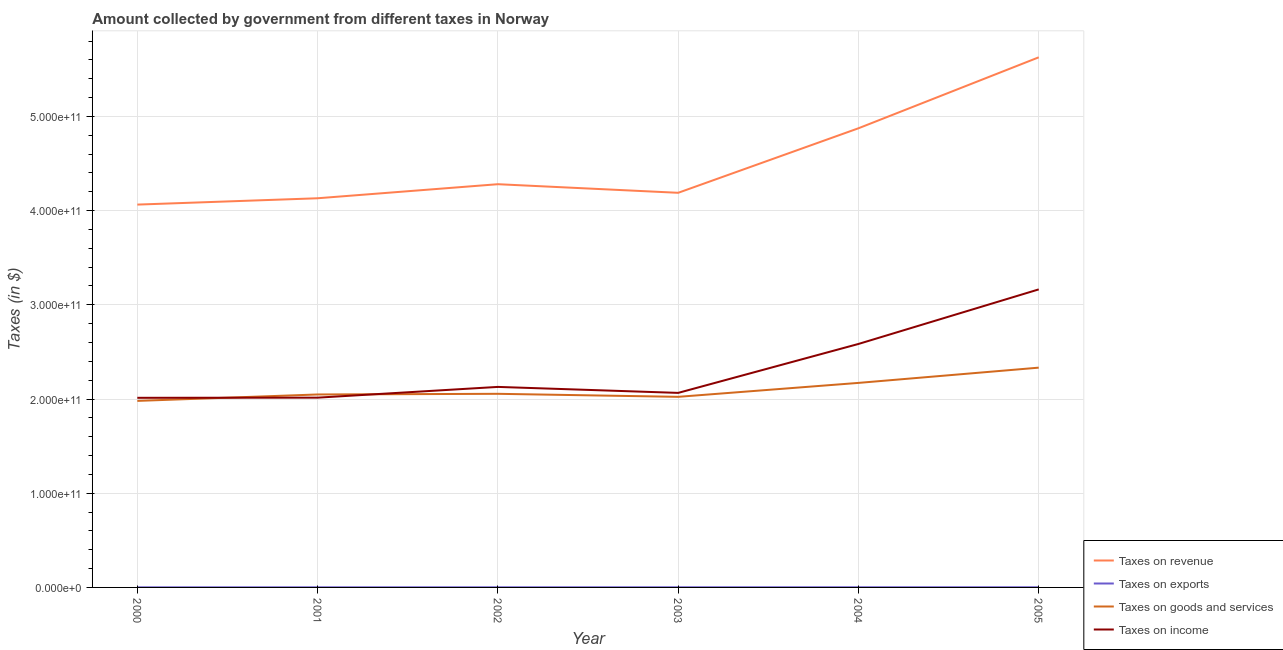Does the line corresponding to amount collected as tax on revenue intersect with the line corresponding to amount collected as tax on exports?
Your response must be concise. No. What is the amount collected as tax on goods in 2001?
Make the answer very short. 2.05e+11. Across all years, what is the maximum amount collected as tax on goods?
Give a very brief answer. 2.33e+11. Across all years, what is the minimum amount collected as tax on revenue?
Give a very brief answer. 4.06e+11. In which year was the amount collected as tax on exports minimum?
Your answer should be very brief. 2000. What is the total amount collected as tax on income in the graph?
Make the answer very short. 1.40e+12. What is the difference between the amount collected as tax on exports in 2003 and that in 2004?
Offer a very short reply. -2.00e+07. What is the difference between the amount collected as tax on income in 2002 and the amount collected as tax on revenue in 2001?
Your answer should be very brief. -2.00e+11. What is the average amount collected as tax on exports per year?
Ensure brevity in your answer.  1.42e+08. In the year 2000, what is the difference between the amount collected as tax on exports and amount collected as tax on revenue?
Keep it short and to the point. -4.06e+11. In how many years, is the amount collected as tax on exports greater than 160000000000 $?
Provide a succinct answer. 0. What is the ratio of the amount collected as tax on exports in 2002 to that in 2003?
Your response must be concise. 0.87. Is the amount collected as tax on goods in 2001 less than that in 2002?
Keep it short and to the point. Yes. What is the difference between the highest and the second highest amount collected as tax on exports?
Your answer should be very brief. 0. What is the difference between the highest and the lowest amount collected as tax on exports?
Give a very brief answer. 6.00e+07. Is it the case that in every year, the sum of the amount collected as tax on revenue and amount collected as tax on income is greater than the sum of amount collected as tax on goods and amount collected as tax on exports?
Offer a terse response. Yes. Is it the case that in every year, the sum of the amount collected as tax on revenue and amount collected as tax on exports is greater than the amount collected as tax on goods?
Your response must be concise. Yes. Does the amount collected as tax on exports monotonically increase over the years?
Your answer should be compact. No. Is the amount collected as tax on goods strictly greater than the amount collected as tax on income over the years?
Your answer should be very brief. No. Is the amount collected as tax on exports strictly less than the amount collected as tax on income over the years?
Your answer should be compact. Yes. How many lines are there?
Provide a short and direct response. 4. What is the difference between two consecutive major ticks on the Y-axis?
Provide a short and direct response. 1.00e+11. Does the graph contain any zero values?
Provide a short and direct response. No. Where does the legend appear in the graph?
Offer a very short reply. Bottom right. How are the legend labels stacked?
Provide a short and direct response. Vertical. What is the title of the graph?
Give a very brief answer. Amount collected by government from different taxes in Norway. What is the label or title of the X-axis?
Ensure brevity in your answer.  Year. What is the label or title of the Y-axis?
Offer a terse response. Taxes (in $). What is the Taxes (in $) in Taxes on revenue in 2000?
Give a very brief answer. 4.06e+11. What is the Taxes (in $) of Taxes on exports in 2000?
Your answer should be compact. 1.10e+08. What is the Taxes (in $) of Taxes on goods and services in 2000?
Ensure brevity in your answer.  1.98e+11. What is the Taxes (in $) in Taxes on income in 2000?
Provide a short and direct response. 2.01e+11. What is the Taxes (in $) of Taxes on revenue in 2001?
Keep it short and to the point. 4.13e+11. What is the Taxes (in $) in Taxes on exports in 2001?
Offer a very short reply. 1.20e+08. What is the Taxes (in $) of Taxes on goods and services in 2001?
Give a very brief answer. 2.05e+11. What is the Taxes (in $) of Taxes on income in 2001?
Provide a succinct answer. 2.01e+11. What is the Taxes (in $) of Taxes on revenue in 2002?
Give a very brief answer. 4.28e+11. What is the Taxes (in $) in Taxes on exports in 2002?
Your answer should be compact. 1.30e+08. What is the Taxes (in $) of Taxes on goods and services in 2002?
Provide a succinct answer. 2.06e+11. What is the Taxes (in $) in Taxes on income in 2002?
Make the answer very short. 2.13e+11. What is the Taxes (in $) in Taxes on revenue in 2003?
Your response must be concise. 4.19e+11. What is the Taxes (in $) of Taxes on exports in 2003?
Your answer should be very brief. 1.50e+08. What is the Taxes (in $) of Taxes on goods and services in 2003?
Your answer should be very brief. 2.02e+11. What is the Taxes (in $) in Taxes on income in 2003?
Make the answer very short. 2.06e+11. What is the Taxes (in $) in Taxes on revenue in 2004?
Your answer should be very brief. 4.87e+11. What is the Taxes (in $) of Taxes on exports in 2004?
Your response must be concise. 1.70e+08. What is the Taxes (in $) of Taxes on goods and services in 2004?
Make the answer very short. 2.17e+11. What is the Taxes (in $) of Taxes on income in 2004?
Offer a very short reply. 2.58e+11. What is the Taxes (in $) in Taxes on revenue in 2005?
Provide a succinct answer. 5.63e+11. What is the Taxes (in $) of Taxes on exports in 2005?
Your answer should be compact. 1.70e+08. What is the Taxes (in $) of Taxes on goods and services in 2005?
Offer a very short reply. 2.33e+11. What is the Taxes (in $) in Taxes on income in 2005?
Your answer should be compact. 3.16e+11. Across all years, what is the maximum Taxes (in $) of Taxes on revenue?
Provide a succinct answer. 5.63e+11. Across all years, what is the maximum Taxes (in $) of Taxes on exports?
Your response must be concise. 1.70e+08. Across all years, what is the maximum Taxes (in $) of Taxes on goods and services?
Provide a short and direct response. 2.33e+11. Across all years, what is the maximum Taxes (in $) of Taxes on income?
Your answer should be very brief. 3.16e+11. Across all years, what is the minimum Taxes (in $) of Taxes on revenue?
Offer a terse response. 4.06e+11. Across all years, what is the minimum Taxes (in $) of Taxes on exports?
Ensure brevity in your answer.  1.10e+08. Across all years, what is the minimum Taxes (in $) of Taxes on goods and services?
Your response must be concise. 1.98e+11. Across all years, what is the minimum Taxes (in $) in Taxes on income?
Provide a short and direct response. 2.01e+11. What is the total Taxes (in $) in Taxes on revenue in the graph?
Your response must be concise. 2.72e+12. What is the total Taxes (in $) in Taxes on exports in the graph?
Your response must be concise. 8.50e+08. What is the total Taxes (in $) of Taxes on goods and services in the graph?
Your answer should be compact. 1.26e+12. What is the total Taxes (in $) in Taxes on income in the graph?
Provide a succinct answer. 1.40e+12. What is the difference between the Taxes (in $) of Taxes on revenue in 2000 and that in 2001?
Offer a terse response. -6.72e+09. What is the difference between the Taxes (in $) of Taxes on exports in 2000 and that in 2001?
Provide a short and direct response. -1.00e+07. What is the difference between the Taxes (in $) in Taxes on goods and services in 2000 and that in 2001?
Make the answer very short. -6.82e+09. What is the difference between the Taxes (in $) of Taxes on income in 2000 and that in 2001?
Provide a short and direct response. -1.79e+08. What is the difference between the Taxes (in $) in Taxes on revenue in 2000 and that in 2002?
Ensure brevity in your answer.  -2.16e+1. What is the difference between the Taxes (in $) of Taxes on exports in 2000 and that in 2002?
Your response must be concise. -2.00e+07. What is the difference between the Taxes (in $) in Taxes on goods and services in 2000 and that in 2002?
Offer a very short reply. -7.52e+09. What is the difference between the Taxes (in $) in Taxes on income in 2000 and that in 2002?
Provide a short and direct response. -1.16e+1. What is the difference between the Taxes (in $) of Taxes on revenue in 2000 and that in 2003?
Your answer should be compact. -1.25e+1. What is the difference between the Taxes (in $) of Taxes on exports in 2000 and that in 2003?
Give a very brief answer. -4.00e+07. What is the difference between the Taxes (in $) of Taxes on goods and services in 2000 and that in 2003?
Ensure brevity in your answer.  -4.31e+09. What is the difference between the Taxes (in $) in Taxes on income in 2000 and that in 2003?
Your response must be concise. -5.23e+09. What is the difference between the Taxes (in $) in Taxes on revenue in 2000 and that in 2004?
Provide a short and direct response. -8.10e+1. What is the difference between the Taxes (in $) of Taxes on exports in 2000 and that in 2004?
Provide a short and direct response. -6.00e+07. What is the difference between the Taxes (in $) of Taxes on goods and services in 2000 and that in 2004?
Offer a very short reply. -1.91e+1. What is the difference between the Taxes (in $) in Taxes on income in 2000 and that in 2004?
Keep it short and to the point. -5.72e+1. What is the difference between the Taxes (in $) of Taxes on revenue in 2000 and that in 2005?
Give a very brief answer. -1.56e+11. What is the difference between the Taxes (in $) of Taxes on exports in 2000 and that in 2005?
Your answer should be compact. -6.00e+07. What is the difference between the Taxes (in $) of Taxes on goods and services in 2000 and that in 2005?
Make the answer very short. -3.53e+1. What is the difference between the Taxes (in $) of Taxes on income in 2000 and that in 2005?
Ensure brevity in your answer.  -1.15e+11. What is the difference between the Taxes (in $) in Taxes on revenue in 2001 and that in 2002?
Offer a terse response. -1.49e+1. What is the difference between the Taxes (in $) of Taxes on exports in 2001 and that in 2002?
Provide a succinct answer. -1.00e+07. What is the difference between the Taxes (in $) of Taxes on goods and services in 2001 and that in 2002?
Make the answer very short. -6.98e+08. What is the difference between the Taxes (in $) of Taxes on income in 2001 and that in 2002?
Give a very brief answer. -1.14e+1. What is the difference between the Taxes (in $) of Taxes on revenue in 2001 and that in 2003?
Provide a short and direct response. -5.80e+09. What is the difference between the Taxes (in $) of Taxes on exports in 2001 and that in 2003?
Offer a terse response. -3.00e+07. What is the difference between the Taxes (in $) of Taxes on goods and services in 2001 and that in 2003?
Provide a succinct answer. 2.51e+09. What is the difference between the Taxes (in $) in Taxes on income in 2001 and that in 2003?
Give a very brief answer. -5.05e+09. What is the difference between the Taxes (in $) in Taxes on revenue in 2001 and that in 2004?
Your response must be concise. -7.43e+1. What is the difference between the Taxes (in $) of Taxes on exports in 2001 and that in 2004?
Keep it short and to the point. -5.00e+07. What is the difference between the Taxes (in $) in Taxes on goods and services in 2001 and that in 2004?
Your answer should be very brief. -1.23e+1. What is the difference between the Taxes (in $) in Taxes on income in 2001 and that in 2004?
Give a very brief answer. -5.70e+1. What is the difference between the Taxes (in $) in Taxes on revenue in 2001 and that in 2005?
Offer a very short reply. -1.50e+11. What is the difference between the Taxes (in $) of Taxes on exports in 2001 and that in 2005?
Offer a terse response. -5.00e+07. What is the difference between the Taxes (in $) in Taxes on goods and services in 2001 and that in 2005?
Make the answer very short. -2.85e+1. What is the difference between the Taxes (in $) in Taxes on income in 2001 and that in 2005?
Offer a very short reply. -1.15e+11. What is the difference between the Taxes (in $) in Taxes on revenue in 2002 and that in 2003?
Your answer should be compact. 9.12e+09. What is the difference between the Taxes (in $) in Taxes on exports in 2002 and that in 2003?
Your answer should be compact. -2.00e+07. What is the difference between the Taxes (in $) in Taxes on goods and services in 2002 and that in 2003?
Give a very brief answer. 3.21e+09. What is the difference between the Taxes (in $) in Taxes on income in 2002 and that in 2003?
Give a very brief answer. 6.36e+09. What is the difference between the Taxes (in $) of Taxes on revenue in 2002 and that in 2004?
Provide a succinct answer. -5.94e+1. What is the difference between the Taxes (in $) of Taxes on exports in 2002 and that in 2004?
Your response must be concise. -4.00e+07. What is the difference between the Taxes (in $) in Taxes on goods and services in 2002 and that in 2004?
Make the answer very short. -1.16e+1. What is the difference between the Taxes (in $) of Taxes on income in 2002 and that in 2004?
Ensure brevity in your answer.  -4.56e+1. What is the difference between the Taxes (in $) in Taxes on revenue in 2002 and that in 2005?
Your response must be concise. -1.35e+11. What is the difference between the Taxes (in $) in Taxes on exports in 2002 and that in 2005?
Provide a succinct answer. -4.00e+07. What is the difference between the Taxes (in $) of Taxes on goods and services in 2002 and that in 2005?
Offer a terse response. -2.78e+1. What is the difference between the Taxes (in $) of Taxes on income in 2002 and that in 2005?
Provide a succinct answer. -1.04e+11. What is the difference between the Taxes (in $) of Taxes on revenue in 2003 and that in 2004?
Provide a succinct answer. -6.85e+1. What is the difference between the Taxes (in $) of Taxes on exports in 2003 and that in 2004?
Give a very brief answer. -2.00e+07. What is the difference between the Taxes (in $) of Taxes on goods and services in 2003 and that in 2004?
Your response must be concise. -1.48e+1. What is the difference between the Taxes (in $) of Taxes on income in 2003 and that in 2004?
Provide a succinct answer. -5.19e+1. What is the difference between the Taxes (in $) of Taxes on revenue in 2003 and that in 2005?
Offer a terse response. -1.44e+11. What is the difference between the Taxes (in $) in Taxes on exports in 2003 and that in 2005?
Make the answer very short. -2.00e+07. What is the difference between the Taxes (in $) of Taxes on goods and services in 2003 and that in 2005?
Offer a terse response. -3.10e+1. What is the difference between the Taxes (in $) of Taxes on income in 2003 and that in 2005?
Your answer should be compact. -1.10e+11. What is the difference between the Taxes (in $) of Taxes on revenue in 2004 and that in 2005?
Your answer should be compact. -7.53e+1. What is the difference between the Taxes (in $) of Taxes on exports in 2004 and that in 2005?
Provide a short and direct response. 0. What is the difference between the Taxes (in $) in Taxes on goods and services in 2004 and that in 2005?
Offer a terse response. -1.62e+1. What is the difference between the Taxes (in $) in Taxes on income in 2004 and that in 2005?
Make the answer very short. -5.79e+1. What is the difference between the Taxes (in $) of Taxes on revenue in 2000 and the Taxes (in $) of Taxes on exports in 2001?
Your answer should be very brief. 4.06e+11. What is the difference between the Taxes (in $) of Taxes on revenue in 2000 and the Taxes (in $) of Taxes on goods and services in 2001?
Your answer should be compact. 2.02e+11. What is the difference between the Taxes (in $) of Taxes on revenue in 2000 and the Taxes (in $) of Taxes on income in 2001?
Offer a terse response. 2.05e+11. What is the difference between the Taxes (in $) of Taxes on exports in 2000 and the Taxes (in $) of Taxes on goods and services in 2001?
Offer a very short reply. -2.05e+11. What is the difference between the Taxes (in $) in Taxes on exports in 2000 and the Taxes (in $) in Taxes on income in 2001?
Ensure brevity in your answer.  -2.01e+11. What is the difference between the Taxes (in $) in Taxes on goods and services in 2000 and the Taxes (in $) in Taxes on income in 2001?
Offer a terse response. -3.44e+09. What is the difference between the Taxes (in $) in Taxes on revenue in 2000 and the Taxes (in $) in Taxes on exports in 2002?
Give a very brief answer. 4.06e+11. What is the difference between the Taxes (in $) of Taxes on revenue in 2000 and the Taxes (in $) of Taxes on goods and services in 2002?
Offer a very short reply. 2.01e+11. What is the difference between the Taxes (in $) in Taxes on revenue in 2000 and the Taxes (in $) in Taxes on income in 2002?
Give a very brief answer. 1.94e+11. What is the difference between the Taxes (in $) of Taxes on exports in 2000 and the Taxes (in $) of Taxes on goods and services in 2002?
Offer a very short reply. -2.05e+11. What is the difference between the Taxes (in $) in Taxes on exports in 2000 and the Taxes (in $) in Taxes on income in 2002?
Your answer should be very brief. -2.13e+11. What is the difference between the Taxes (in $) of Taxes on goods and services in 2000 and the Taxes (in $) of Taxes on income in 2002?
Offer a very short reply. -1.49e+1. What is the difference between the Taxes (in $) in Taxes on revenue in 2000 and the Taxes (in $) in Taxes on exports in 2003?
Provide a succinct answer. 4.06e+11. What is the difference between the Taxes (in $) in Taxes on revenue in 2000 and the Taxes (in $) in Taxes on goods and services in 2003?
Your response must be concise. 2.04e+11. What is the difference between the Taxes (in $) in Taxes on revenue in 2000 and the Taxes (in $) in Taxes on income in 2003?
Give a very brief answer. 2.00e+11. What is the difference between the Taxes (in $) of Taxes on exports in 2000 and the Taxes (in $) of Taxes on goods and services in 2003?
Give a very brief answer. -2.02e+11. What is the difference between the Taxes (in $) in Taxes on exports in 2000 and the Taxes (in $) in Taxes on income in 2003?
Make the answer very short. -2.06e+11. What is the difference between the Taxes (in $) of Taxes on goods and services in 2000 and the Taxes (in $) of Taxes on income in 2003?
Provide a short and direct response. -8.50e+09. What is the difference between the Taxes (in $) in Taxes on revenue in 2000 and the Taxes (in $) in Taxes on exports in 2004?
Your answer should be compact. 4.06e+11. What is the difference between the Taxes (in $) in Taxes on revenue in 2000 and the Taxes (in $) in Taxes on goods and services in 2004?
Your answer should be compact. 1.89e+11. What is the difference between the Taxes (in $) in Taxes on revenue in 2000 and the Taxes (in $) in Taxes on income in 2004?
Make the answer very short. 1.48e+11. What is the difference between the Taxes (in $) in Taxes on exports in 2000 and the Taxes (in $) in Taxes on goods and services in 2004?
Provide a succinct answer. -2.17e+11. What is the difference between the Taxes (in $) of Taxes on exports in 2000 and the Taxes (in $) of Taxes on income in 2004?
Make the answer very short. -2.58e+11. What is the difference between the Taxes (in $) in Taxes on goods and services in 2000 and the Taxes (in $) in Taxes on income in 2004?
Your answer should be compact. -6.04e+1. What is the difference between the Taxes (in $) of Taxes on revenue in 2000 and the Taxes (in $) of Taxes on exports in 2005?
Offer a very short reply. 4.06e+11. What is the difference between the Taxes (in $) in Taxes on revenue in 2000 and the Taxes (in $) in Taxes on goods and services in 2005?
Provide a succinct answer. 1.73e+11. What is the difference between the Taxes (in $) of Taxes on revenue in 2000 and the Taxes (in $) of Taxes on income in 2005?
Ensure brevity in your answer.  9.00e+1. What is the difference between the Taxes (in $) of Taxes on exports in 2000 and the Taxes (in $) of Taxes on goods and services in 2005?
Offer a very short reply. -2.33e+11. What is the difference between the Taxes (in $) in Taxes on exports in 2000 and the Taxes (in $) in Taxes on income in 2005?
Keep it short and to the point. -3.16e+11. What is the difference between the Taxes (in $) of Taxes on goods and services in 2000 and the Taxes (in $) of Taxes on income in 2005?
Give a very brief answer. -1.18e+11. What is the difference between the Taxes (in $) of Taxes on revenue in 2001 and the Taxes (in $) of Taxes on exports in 2002?
Provide a succinct answer. 4.13e+11. What is the difference between the Taxes (in $) of Taxes on revenue in 2001 and the Taxes (in $) of Taxes on goods and services in 2002?
Make the answer very short. 2.08e+11. What is the difference between the Taxes (in $) of Taxes on revenue in 2001 and the Taxes (in $) of Taxes on income in 2002?
Offer a terse response. 2.00e+11. What is the difference between the Taxes (in $) of Taxes on exports in 2001 and the Taxes (in $) of Taxes on goods and services in 2002?
Your answer should be compact. -2.05e+11. What is the difference between the Taxes (in $) in Taxes on exports in 2001 and the Taxes (in $) in Taxes on income in 2002?
Your response must be concise. -2.13e+11. What is the difference between the Taxes (in $) of Taxes on goods and services in 2001 and the Taxes (in $) of Taxes on income in 2002?
Provide a succinct answer. -8.03e+09. What is the difference between the Taxes (in $) of Taxes on revenue in 2001 and the Taxes (in $) of Taxes on exports in 2003?
Your response must be concise. 4.13e+11. What is the difference between the Taxes (in $) in Taxes on revenue in 2001 and the Taxes (in $) in Taxes on goods and services in 2003?
Keep it short and to the point. 2.11e+11. What is the difference between the Taxes (in $) of Taxes on revenue in 2001 and the Taxes (in $) of Taxes on income in 2003?
Keep it short and to the point. 2.07e+11. What is the difference between the Taxes (in $) in Taxes on exports in 2001 and the Taxes (in $) in Taxes on goods and services in 2003?
Keep it short and to the point. -2.02e+11. What is the difference between the Taxes (in $) of Taxes on exports in 2001 and the Taxes (in $) of Taxes on income in 2003?
Provide a short and direct response. -2.06e+11. What is the difference between the Taxes (in $) in Taxes on goods and services in 2001 and the Taxes (in $) in Taxes on income in 2003?
Give a very brief answer. -1.67e+09. What is the difference between the Taxes (in $) of Taxes on revenue in 2001 and the Taxes (in $) of Taxes on exports in 2004?
Ensure brevity in your answer.  4.13e+11. What is the difference between the Taxes (in $) in Taxes on revenue in 2001 and the Taxes (in $) in Taxes on goods and services in 2004?
Offer a terse response. 1.96e+11. What is the difference between the Taxes (in $) of Taxes on revenue in 2001 and the Taxes (in $) of Taxes on income in 2004?
Your response must be concise. 1.55e+11. What is the difference between the Taxes (in $) of Taxes on exports in 2001 and the Taxes (in $) of Taxes on goods and services in 2004?
Offer a terse response. -2.17e+11. What is the difference between the Taxes (in $) of Taxes on exports in 2001 and the Taxes (in $) of Taxes on income in 2004?
Your answer should be compact. -2.58e+11. What is the difference between the Taxes (in $) in Taxes on goods and services in 2001 and the Taxes (in $) in Taxes on income in 2004?
Ensure brevity in your answer.  -5.36e+1. What is the difference between the Taxes (in $) of Taxes on revenue in 2001 and the Taxes (in $) of Taxes on exports in 2005?
Keep it short and to the point. 4.13e+11. What is the difference between the Taxes (in $) in Taxes on revenue in 2001 and the Taxes (in $) in Taxes on goods and services in 2005?
Your response must be concise. 1.80e+11. What is the difference between the Taxes (in $) of Taxes on revenue in 2001 and the Taxes (in $) of Taxes on income in 2005?
Make the answer very short. 9.67e+1. What is the difference between the Taxes (in $) in Taxes on exports in 2001 and the Taxes (in $) in Taxes on goods and services in 2005?
Offer a terse response. -2.33e+11. What is the difference between the Taxes (in $) of Taxes on exports in 2001 and the Taxes (in $) of Taxes on income in 2005?
Offer a terse response. -3.16e+11. What is the difference between the Taxes (in $) of Taxes on goods and services in 2001 and the Taxes (in $) of Taxes on income in 2005?
Offer a very short reply. -1.12e+11. What is the difference between the Taxes (in $) of Taxes on revenue in 2002 and the Taxes (in $) of Taxes on exports in 2003?
Keep it short and to the point. 4.28e+11. What is the difference between the Taxes (in $) of Taxes on revenue in 2002 and the Taxes (in $) of Taxes on goods and services in 2003?
Offer a terse response. 2.26e+11. What is the difference between the Taxes (in $) in Taxes on revenue in 2002 and the Taxes (in $) in Taxes on income in 2003?
Your answer should be compact. 2.22e+11. What is the difference between the Taxes (in $) in Taxes on exports in 2002 and the Taxes (in $) in Taxes on goods and services in 2003?
Provide a succinct answer. -2.02e+11. What is the difference between the Taxes (in $) in Taxes on exports in 2002 and the Taxes (in $) in Taxes on income in 2003?
Your answer should be compact. -2.06e+11. What is the difference between the Taxes (in $) of Taxes on goods and services in 2002 and the Taxes (in $) of Taxes on income in 2003?
Make the answer very short. -9.76e+08. What is the difference between the Taxes (in $) of Taxes on revenue in 2002 and the Taxes (in $) of Taxes on exports in 2004?
Make the answer very short. 4.28e+11. What is the difference between the Taxes (in $) of Taxes on revenue in 2002 and the Taxes (in $) of Taxes on goods and services in 2004?
Offer a very short reply. 2.11e+11. What is the difference between the Taxes (in $) in Taxes on revenue in 2002 and the Taxes (in $) in Taxes on income in 2004?
Keep it short and to the point. 1.70e+11. What is the difference between the Taxes (in $) in Taxes on exports in 2002 and the Taxes (in $) in Taxes on goods and services in 2004?
Provide a short and direct response. -2.17e+11. What is the difference between the Taxes (in $) of Taxes on exports in 2002 and the Taxes (in $) of Taxes on income in 2004?
Make the answer very short. -2.58e+11. What is the difference between the Taxes (in $) of Taxes on goods and services in 2002 and the Taxes (in $) of Taxes on income in 2004?
Offer a terse response. -5.29e+1. What is the difference between the Taxes (in $) in Taxes on revenue in 2002 and the Taxes (in $) in Taxes on exports in 2005?
Offer a terse response. 4.28e+11. What is the difference between the Taxes (in $) in Taxes on revenue in 2002 and the Taxes (in $) in Taxes on goods and services in 2005?
Offer a very short reply. 1.95e+11. What is the difference between the Taxes (in $) in Taxes on revenue in 2002 and the Taxes (in $) in Taxes on income in 2005?
Your answer should be compact. 1.12e+11. What is the difference between the Taxes (in $) of Taxes on exports in 2002 and the Taxes (in $) of Taxes on goods and services in 2005?
Provide a succinct answer. -2.33e+11. What is the difference between the Taxes (in $) of Taxes on exports in 2002 and the Taxes (in $) of Taxes on income in 2005?
Ensure brevity in your answer.  -3.16e+11. What is the difference between the Taxes (in $) of Taxes on goods and services in 2002 and the Taxes (in $) of Taxes on income in 2005?
Your answer should be very brief. -1.11e+11. What is the difference between the Taxes (in $) of Taxes on revenue in 2003 and the Taxes (in $) of Taxes on exports in 2004?
Provide a succinct answer. 4.19e+11. What is the difference between the Taxes (in $) in Taxes on revenue in 2003 and the Taxes (in $) in Taxes on goods and services in 2004?
Give a very brief answer. 2.02e+11. What is the difference between the Taxes (in $) in Taxes on revenue in 2003 and the Taxes (in $) in Taxes on income in 2004?
Give a very brief answer. 1.60e+11. What is the difference between the Taxes (in $) in Taxes on exports in 2003 and the Taxes (in $) in Taxes on goods and services in 2004?
Provide a succinct answer. -2.17e+11. What is the difference between the Taxes (in $) of Taxes on exports in 2003 and the Taxes (in $) of Taxes on income in 2004?
Your answer should be very brief. -2.58e+11. What is the difference between the Taxes (in $) of Taxes on goods and services in 2003 and the Taxes (in $) of Taxes on income in 2004?
Ensure brevity in your answer.  -5.61e+1. What is the difference between the Taxes (in $) of Taxes on revenue in 2003 and the Taxes (in $) of Taxes on exports in 2005?
Provide a short and direct response. 4.19e+11. What is the difference between the Taxes (in $) in Taxes on revenue in 2003 and the Taxes (in $) in Taxes on goods and services in 2005?
Offer a very short reply. 1.86e+11. What is the difference between the Taxes (in $) in Taxes on revenue in 2003 and the Taxes (in $) in Taxes on income in 2005?
Offer a terse response. 1.03e+11. What is the difference between the Taxes (in $) of Taxes on exports in 2003 and the Taxes (in $) of Taxes on goods and services in 2005?
Your answer should be compact. -2.33e+11. What is the difference between the Taxes (in $) of Taxes on exports in 2003 and the Taxes (in $) of Taxes on income in 2005?
Give a very brief answer. -3.16e+11. What is the difference between the Taxes (in $) in Taxes on goods and services in 2003 and the Taxes (in $) in Taxes on income in 2005?
Provide a succinct answer. -1.14e+11. What is the difference between the Taxes (in $) in Taxes on revenue in 2004 and the Taxes (in $) in Taxes on exports in 2005?
Ensure brevity in your answer.  4.87e+11. What is the difference between the Taxes (in $) of Taxes on revenue in 2004 and the Taxes (in $) of Taxes on goods and services in 2005?
Keep it short and to the point. 2.54e+11. What is the difference between the Taxes (in $) in Taxes on revenue in 2004 and the Taxes (in $) in Taxes on income in 2005?
Provide a succinct answer. 1.71e+11. What is the difference between the Taxes (in $) in Taxes on exports in 2004 and the Taxes (in $) in Taxes on goods and services in 2005?
Keep it short and to the point. -2.33e+11. What is the difference between the Taxes (in $) of Taxes on exports in 2004 and the Taxes (in $) of Taxes on income in 2005?
Give a very brief answer. -3.16e+11. What is the difference between the Taxes (in $) in Taxes on goods and services in 2004 and the Taxes (in $) in Taxes on income in 2005?
Offer a very short reply. -9.93e+1. What is the average Taxes (in $) of Taxes on revenue per year?
Offer a terse response. 4.53e+11. What is the average Taxes (in $) in Taxes on exports per year?
Offer a terse response. 1.42e+08. What is the average Taxes (in $) in Taxes on goods and services per year?
Provide a succinct answer. 2.10e+11. What is the average Taxes (in $) in Taxes on income per year?
Keep it short and to the point. 2.33e+11. In the year 2000, what is the difference between the Taxes (in $) in Taxes on revenue and Taxes (in $) in Taxes on exports?
Keep it short and to the point. 4.06e+11. In the year 2000, what is the difference between the Taxes (in $) of Taxes on revenue and Taxes (in $) of Taxes on goods and services?
Offer a terse response. 2.08e+11. In the year 2000, what is the difference between the Taxes (in $) in Taxes on revenue and Taxes (in $) in Taxes on income?
Offer a very short reply. 2.05e+11. In the year 2000, what is the difference between the Taxes (in $) of Taxes on exports and Taxes (in $) of Taxes on goods and services?
Offer a very short reply. -1.98e+11. In the year 2000, what is the difference between the Taxes (in $) in Taxes on exports and Taxes (in $) in Taxes on income?
Keep it short and to the point. -2.01e+11. In the year 2000, what is the difference between the Taxes (in $) in Taxes on goods and services and Taxes (in $) in Taxes on income?
Provide a succinct answer. -3.26e+09. In the year 2001, what is the difference between the Taxes (in $) in Taxes on revenue and Taxes (in $) in Taxes on exports?
Provide a short and direct response. 4.13e+11. In the year 2001, what is the difference between the Taxes (in $) in Taxes on revenue and Taxes (in $) in Taxes on goods and services?
Offer a very short reply. 2.08e+11. In the year 2001, what is the difference between the Taxes (in $) in Taxes on revenue and Taxes (in $) in Taxes on income?
Provide a short and direct response. 2.12e+11. In the year 2001, what is the difference between the Taxes (in $) of Taxes on exports and Taxes (in $) of Taxes on goods and services?
Make the answer very short. -2.05e+11. In the year 2001, what is the difference between the Taxes (in $) of Taxes on exports and Taxes (in $) of Taxes on income?
Make the answer very short. -2.01e+11. In the year 2001, what is the difference between the Taxes (in $) in Taxes on goods and services and Taxes (in $) in Taxes on income?
Ensure brevity in your answer.  3.38e+09. In the year 2002, what is the difference between the Taxes (in $) in Taxes on revenue and Taxes (in $) in Taxes on exports?
Your response must be concise. 4.28e+11. In the year 2002, what is the difference between the Taxes (in $) of Taxes on revenue and Taxes (in $) of Taxes on goods and services?
Your answer should be very brief. 2.22e+11. In the year 2002, what is the difference between the Taxes (in $) of Taxes on revenue and Taxes (in $) of Taxes on income?
Ensure brevity in your answer.  2.15e+11. In the year 2002, what is the difference between the Taxes (in $) of Taxes on exports and Taxes (in $) of Taxes on goods and services?
Provide a short and direct response. -2.05e+11. In the year 2002, what is the difference between the Taxes (in $) in Taxes on exports and Taxes (in $) in Taxes on income?
Keep it short and to the point. -2.13e+11. In the year 2002, what is the difference between the Taxes (in $) of Taxes on goods and services and Taxes (in $) of Taxes on income?
Give a very brief answer. -7.34e+09. In the year 2003, what is the difference between the Taxes (in $) in Taxes on revenue and Taxes (in $) in Taxes on exports?
Give a very brief answer. 4.19e+11. In the year 2003, what is the difference between the Taxes (in $) of Taxes on revenue and Taxes (in $) of Taxes on goods and services?
Make the answer very short. 2.17e+11. In the year 2003, what is the difference between the Taxes (in $) in Taxes on revenue and Taxes (in $) in Taxes on income?
Ensure brevity in your answer.  2.12e+11. In the year 2003, what is the difference between the Taxes (in $) in Taxes on exports and Taxes (in $) in Taxes on goods and services?
Provide a short and direct response. -2.02e+11. In the year 2003, what is the difference between the Taxes (in $) in Taxes on exports and Taxes (in $) in Taxes on income?
Offer a very short reply. -2.06e+11. In the year 2003, what is the difference between the Taxes (in $) of Taxes on goods and services and Taxes (in $) of Taxes on income?
Provide a short and direct response. -4.18e+09. In the year 2004, what is the difference between the Taxes (in $) in Taxes on revenue and Taxes (in $) in Taxes on exports?
Your answer should be very brief. 4.87e+11. In the year 2004, what is the difference between the Taxes (in $) in Taxes on revenue and Taxes (in $) in Taxes on goods and services?
Your response must be concise. 2.70e+11. In the year 2004, what is the difference between the Taxes (in $) of Taxes on revenue and Taxes (in $) of Taxes on income?
Offer a very short reply. 2.29e+11. In the year 2004, what is the difference between the Taxes (in $) of Taxes on exports and Taxes (in $) of Taxes on goods and services?
Ensure brevity in your answer.  -2.17e+11. In the year 2004, what is the difference between the Taxes (in $) in Taxes on exports and Taxes (in $) in Taxes on income?
Give a very brief answer. -2.58e+11. In the year 2004, what is the difference between the Taxes (in $) in Taxes on goods and services and Taxes (in $) in Taxes on income?
Keep it short and to the point. -4.13e+1. In the year 2005, what is the difference between the Taxes (in $) in Taxes on revenue and Taxes (in $) in Taxes on exports?
Offer a very short reply. 5.63e+11. In the year 2005, what is the difference between the Taxes (in $) of Taxes on revenue and Taxes (in $) of Taxes on goods and services?
Keep it short and to the point. 3.29e+11. In the year 2005, what is the difference between the Taxes (in $) in Taxes on revenue and Taxes (in $) in Taxes on income?
Make the answer very short. 2.46e+11. In the year 2005, what is the difference between the Taxes (in $) of Taxes on exports and Taxes (in $) of Taxes on goods and services?
Make the answer very short. -2.33e+11. In the year 2005, what is the difference between the Taxes (in $) in Taxes on exports and Taxes (in $) in Taxes on income?
Provide a short and direct response. -3.16e+11. In the year 2005, what is the difference between the Taxes (in $) in Taxes on goods and services and Taxes (in $) in Taxes on income?
Your response must be concise. -8.31e+1. What is the ratio of the Taxes (in $) in Taxes on revenue in 2000 to that in 2001?
Your answer should be compact. 0.98. What is the ratio of the Taxes (in $) of Taxes on exports in 2000 to that in 2001?
Offer a terse response. 0.92. What is the ratio of the Taxes (in $) of Taxes on goods and services in 2000 to that in 2001?
Your response must be concise. 0.97. What is the ratio of the Taxes (in $) in Taxes on revenue in 2000 to that in 2002?
Your answer should be very brief. 0.95. What is the ratio of the Taxes (in $) in Taxes on exports in 2000 to that in 2002?
Provide a succinct answer. 0.85. What is the ratio of the Taxes (in $) of Taxes on goods and services in 2000 to that in 2002?
Offer a very short reply. 0.96. What is the ratio of the Taxes (in $) of Taxes on income in 2000 to that in 2002?
Keep it short and to the point. 0.95. What is the ratio of the Taxes (in $) in Taxes on revenue in 2000 to that in 2003?
Offer a very short reply. 0.97. What is the ratio of the Taxes (in $) of Taxes on exports in 2000 to that in 2003?
Give a very brief answer. 0.73. What is the ratio of the Taxes (in $) of Taxes on goods and services in 2000 to that in 2003?
Give a very brief answer. 0.98. What is the ratio of the Taxes (in $) in Taxes on income in 2000 to that in 2003?
Your answer should be compact. 0.97. What is the ratio of the Taxes (in $) in Taxes on revenue in 2000 to that in 2004?
Your answer should be very brief. 0.83. What is the ratio of the Taxes (in $) in Taxes on exports in 2000 to that in 2004?
Offer a very short reply. 0.65. What is the ratio of the Taxes (in $) in Taxes on goods and services in 2000 to that in 2004?
Offer a very short reply. 0.91. What is the ratio of the Taxes (in $) in Taxes on income in 2000 to that in 2004?
Provide a short and direct response. 0.78. What is the ratio of the Taxes (in $) in Taxes on revenue in 2000 to that in 2005?
Your answer should be compact. 0.72. What is the ratio of the Taxes (in $) in Taxes on exports in 2000 to that in 2005?
Keep it short and to the point. 0.65. What is the ratio of the Taxes (in $) in Taxes on goods and services in 2000 to that in 2005?
Give a very brief answer. 0.85. What is the ratio of the Taxes (in $) of Taxes on income in 2000 to that in 2005?
Give a very brief answer. 0.64. What is the ratio of the Taxes (in $) of Taxes on revenue in 2001 to that in 2002?
Offer a terse response. 0.97. What is the ratio of the Taxes (in $) in Taxes on exports in 2001 to that in 2002?
Give a very brief answer. 0.92. What is the ratio of the Taxes (in $) in Taxes on income in 2001 to that in 2002?
Your response must be concise. 0.95. What is the ratio of the Taxes (in $) in Taxes on revenue in 2001 to that in 2003?
Your answer should be very brief. 0.99. What is the ratio of the Taxes (in $) in Taxes on goods and services in 2001 to that in 2003?
Ensure brevity in your answer.  1.01. What is the ratio of the Taxes (in $) in Taxes on income in 2001 to that in 2003?
Your answer should be very brief. 0.98. What is the ratio of the Taxes (in $) in Taxes on revenue in 2001 to that in 2004?
Give a very brief answer. 0.85. What is the ratio of the Taxes (in $) of Taxes on exports in 2001 to that in 2004?
Keep it short and to the point. 0.71. What is the ratio of the Taxes (in $) in Taxes on goods and services in 2001 to that in 2004?
Keep it short and to the point. 0.94. What is the ratio of the Taxes (in $) of Taxes on income in 2001 to that in 2004?
Offer a terse response. 0.78. What is the ratio of the Taxes (in $) in Taxes on revenue in 2001 to that in 2005?
Make the answer very short. 0.73. What is the ratio of the Taxes (in $) of Taxes on exports in 2001 to that in 2005?
Your answer should be very brief. 0.71. What is the ratio of the Taxes (in $) in Taxes on goods and services in 2001 to that in 2005?
Give a very brief answer. 0.88. What is the ratio of the Taxes (in $) of Taxes on income in 2001 to that in 2005?
Your answer should be very brief. 0.64. What is the ratio of the Taxes (in $) in Taxes on revenue in 2002 to that in 2003?
Offer a terse response. 1.02. What is the ratio of the Taxes (in $) of Taxes on exports in 2002 to that in 2003?
Offer a terse response. 0.87. What is the ratio of the Taxes (in $) in Taxes on goods and services in 2002 to that in 2003?
Keep it short and to the point. 1.02. What is the ratio of the Taxes (in $) of Taxes on income in 2002 to that in 2003?
Provide a succinct answer. 1.03. What is the ratio of the Taxes (in $) of Taxes on revenue in 2002 to that in 2004?
Ensure brevity in your answer.  0.88. What is the ratio of the Taxes (in $) in Taxes on exports in 2002 to that in 2004?
Offer a very short reply. 0.76. What is the ratio of the Taxes (in $) in Taxes on goods and services in 2002 to that in 2004?
Provide a short and direct response. 0.95. What is the ratio of the Taxes (in $) in Taxes on income in 2002 to that in 2004?
Your answer should be compact. 0.82. What is the ratio of the Taxes (in $) in Taxes on revenue in 2002 to that in 2005?
Provide a short and direct response. 0.76. What is the ratio of the Taxes (in $) in Taxes on exports in 2002 to that in 2005?
Provide a succinct answer. 0.76. What is the ratio of the Taxes (in $) of Taxes on goods and services in 2002 to that in 2005?
Give a very brief answer. 0.88. What is the ratio of the Taxes (in $) of Taxes on income in 2002 to that in 2005?
Offer a terse response. 0.67. What is the ratio of the Taxes (in $) of Taxes on revenue in 2003 to that in 2004?
Make the answer very short. 0.86. What is the ratio of the Taxes (in $) in Taxes on exports in 2003 to that in 2004?
Your answer should be compact. 0.88. What is the ratio of the Taxes (in $) of Taxes on goods and services in 2003 to that in 2004?
Your answer should be compact. 0.93. What is the ratio of the Taxes (in $) of Taxes on income in 2003 to that in 2004?
Ensure brevity in your answer.  0.8. What is the ratio of the Taxes (in $) in Taxes on revenue in 2003 to that in 2005?
Offer a terse response. 0.74. What is the ratio of the Taxes (in $) in Taxes on exports in 2003 to that in 2005?
Make the answer very short. 0.88. What is the ratio of the Taxes (in $) of Taxes on goods and services in 2003 to that in 2005?
Provide a succinct answer. 0.87. What is the ratio of the Taxes (in $) in Taxes on income in 2003 to that in 2005?
Your answer should be very brief. 0.65. What is the ratio of the Taxes (in $) in Taxes on revenue in 2004 to that in 2005?
Offer a terse response. 0.87. What is the ratio of the Taxes (in $) in Taxes on exports in 2004 to that in 2005?
Offer a terse response. 1. What is the ratio of the Taxes (in $) in Taxes on goods and services in 2004 to that in 2005?
Give a very brief answer. 0.93. What is the ratio of the Taxes (in $) of Taxes on income in 2004 to that in 2005?
Provide a short and direct response. 0.82. What is the difference between the highest and the second highest Taxes (in $) of Taxes on revenue?
Keep it short and to the point. 7.53e+1. What is the difference between the highest and the second highest Taxes (in $) in Taxes on exports?
Give a very brief answer. 0. What is the difference between the highest and the second highest Taxes (in $) of Taxes on goods and services?
Offer a terse response. 1.62e+1. What is the difference between the highest and the second highest Taxes (in $) of Taxes on income?
Provide a short and direct response. 5.79e+1. What is the difference between the highest and the lowest Taxes (in $) in Taxes on revenue?
Ensure brevity in your answer.  1.56e+11. What is the difference between the highest and the lowest Taxes (in $) in Taxes on exports?
Offer a terse response. 6.00e+07. What is the difference between the highest and the lowest Taxes (in $) in Taxes on goods and services?
Keep it short and to the point. 3.53e+1. What is the difference between the highest and the lowest Taxes (in $) in Taxes on income?
Give a very brief answer. 1.15e+11. 